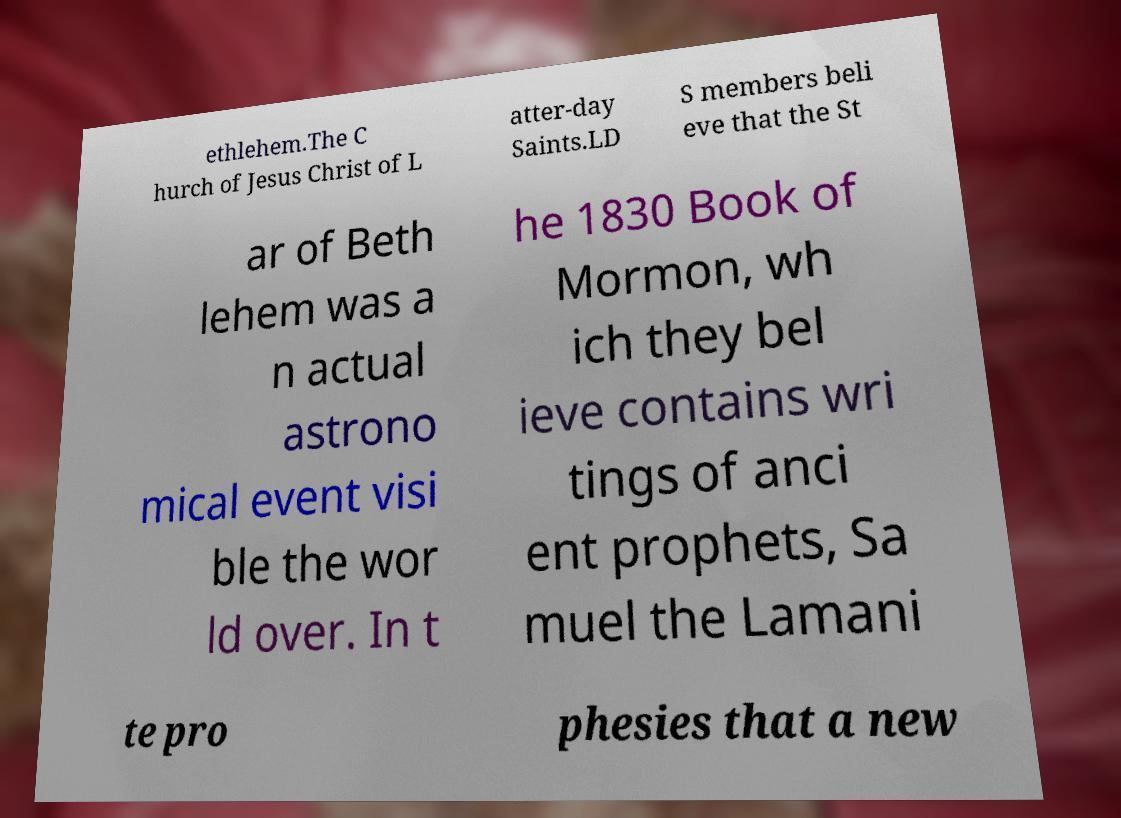Please identify and transcribe the text found in this image. ethlehem.The C hurch of Jesus Christ of L atter-day Saints.LD S members beli eve that the St ar of Beth lehem was a n actual astrono mical event visi ble the wor ld over. In t he 1830 Book of Mormon, wh ich they bel ieve contains wri tings of anci ent prophets, Sa muel the Lamani te pro phesies that a new 